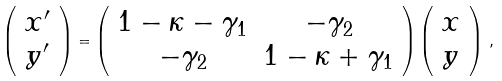Convert formula to latex. <formula><loc_0><loc_0><loc_500><loc_500>\left ( \begin{array} { c } x ^ { \prime } \\ y ^ { \prime } \end{array} \right ) = \left ( \begin{array} { c c } 1 - \kappa - \gamma _ { 1 } & - \gamma _ { 2 } \\ - \gamma _ { 2 } & 1 - \kappa + \gamma _ { 1 } \end{array} \right ) \left ( \begin{array} { c } x \\ y \end{array} \right ) \, ,</formula> 